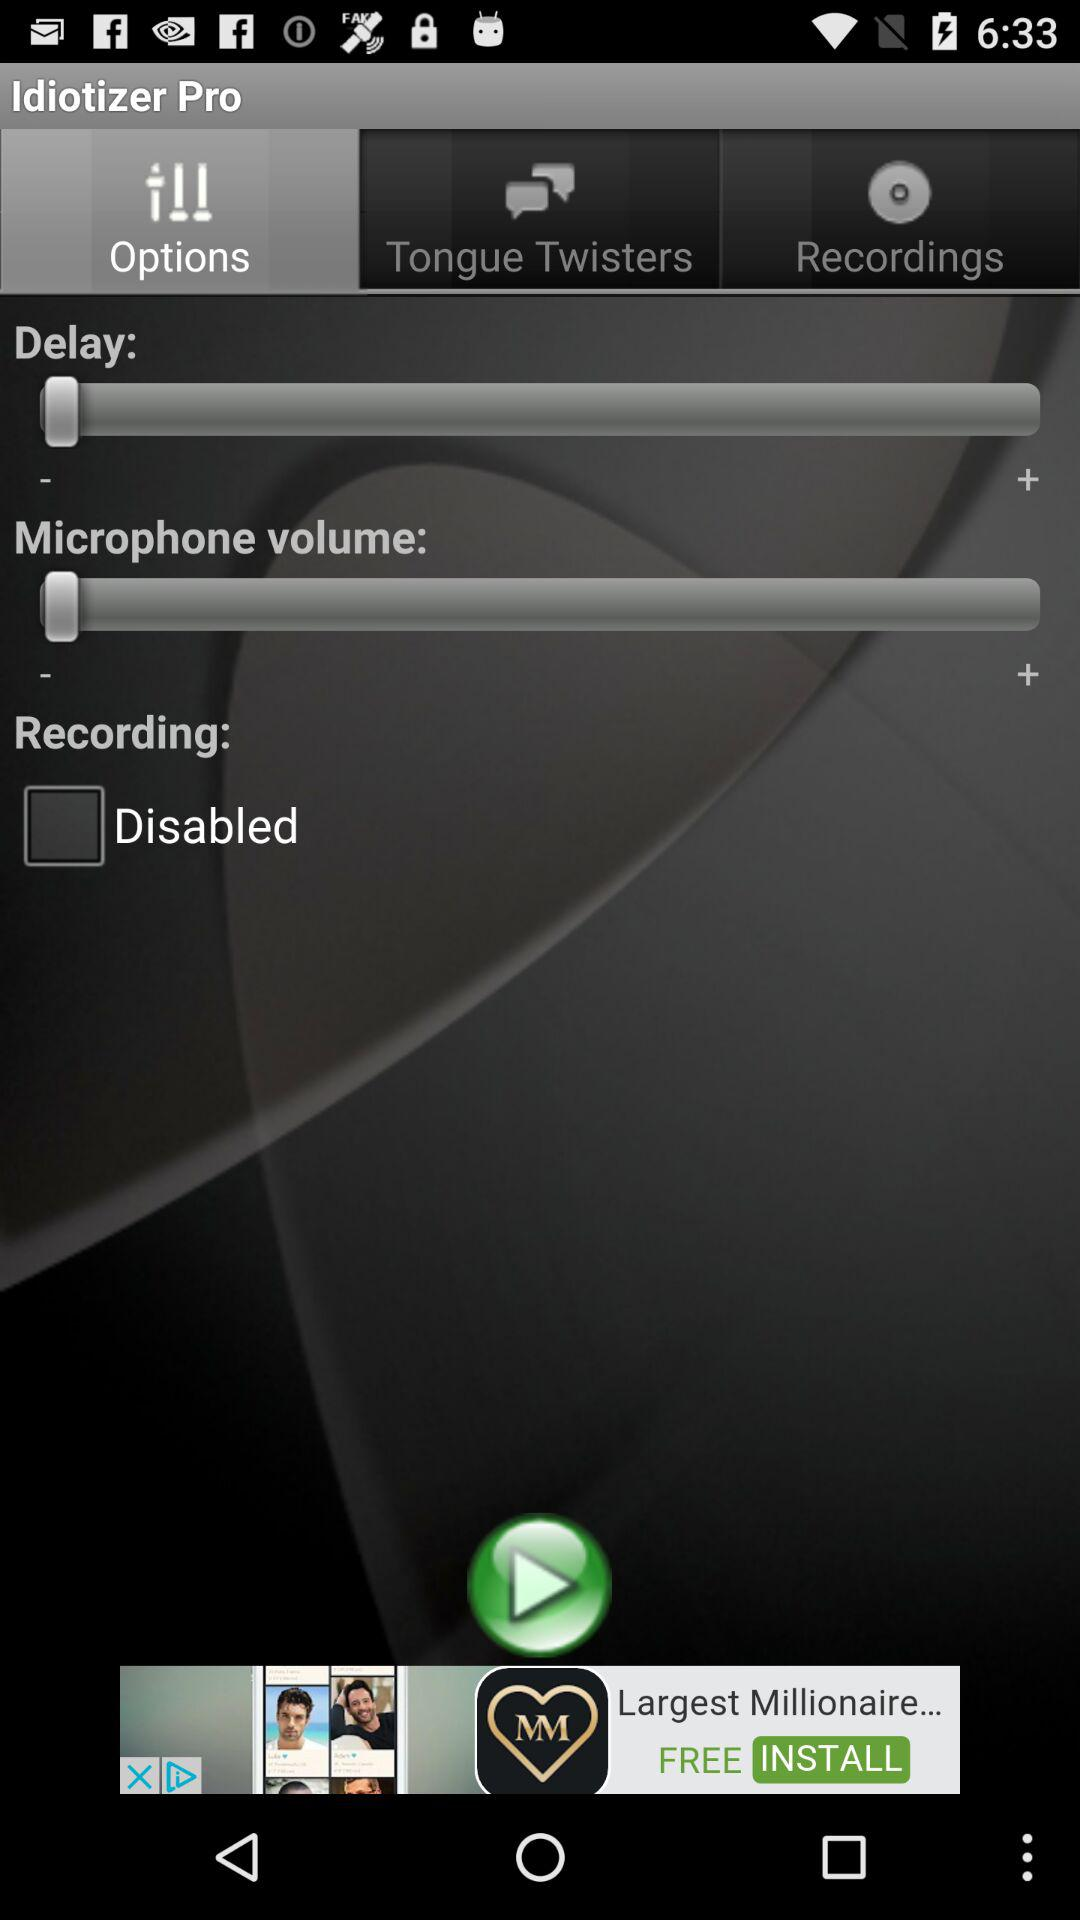Which tab is selected? The selected tab is "Options". 